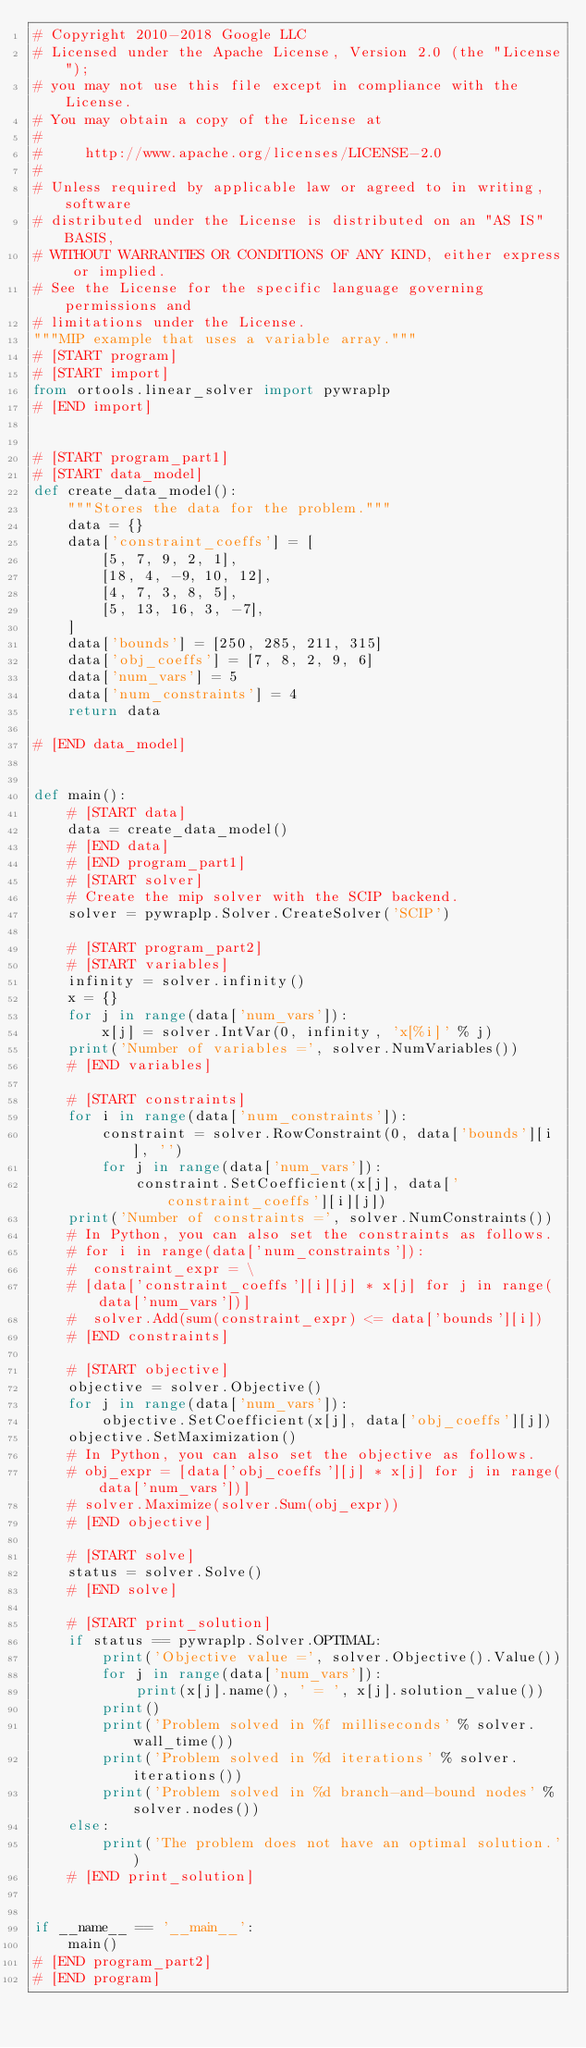Convert code to text. <code><loc_0><loc_0><loc_500><loc_500><_Python_># Copyright 2010-2018 Google LLC
# Licensed under the Apache License, Version 2.0 (the "License");
# you may not use this file except in compliance with the License.
# You may obtain a copy of the License at
#
#     http://www.apache.org/licenses/LICENSE-2.0
#
# Unless required by applicable law or agreed to in writing, software
# distributed under the License is distributed on an "AS IS" BASIS,
# WITHOUT WARRANTIES OR CONDITIONS OF ANY KIND, either express or implied.
# See the License for the specific language governing permissions and
# limitations under the License.
"""MIP example that uses a variable array."""
# [START program]
# [START import]
from ortools.linear_solver import pywraplp
# [END import]


# [START program_part1]
# [START data_model]
def create_data_model():
    """Stores the data for the problem."""
    data = {}
    data['constraint_coeffs'] = [
        [5, 7, 9, 2, 1],
        [18, 4, -9, 10, 12],
        [4, 7, 3, 8, 5],
        [5, 13, 16, 3, -7],
    ]
    data['bounds'] = [250, 285, 211, 315]
    data['obj_coeffs'] = [7, 8, 2, 9, 6]
    data['num_vars'] = 5
    data['num_constraints'] = 4
    return data

# [END data_model]


def main():
    # [START data]
    data = create_data_model()
    # [END data]
    # [END program_part1]
    # [START solver]
    # Create the mip solver with the SCIP backend.
    solver = pywraplp.Solver.CreateSolver('SCIP')

    # [START program_part2]
    # [START variables]
    infinity = solver.infinity()
    x = {}
    for j in range(data['num_vars']):
        x[j] = solver.IntVar(0, infinity, 'x[%i]' % j)
    print('Number of variables =', solver.NumVariables())
    # [END variables]

    # [START constraints]
    for i in range(data['num_constraints']):
        constraint = solver.RowConstraint(0, data['bounds'][i], '')
        for j in range(data['num_vars']):
            constraint.SetCoefficient(x[j], data['constraint_coeffs'][i][j])
    print('Number of constraints =', solver.NumConstraints())
    # In Python, you can also set the constraints as follows.
    # for i in range(data['num_constraints']):
    #  constraint_expr = \
    # [data['constraint_coeffs'][i][j] * x[j] for j in range(data['num_vars'])]
    #  solver.Add(sum(constraint_expr) <= data['bounds'][i])
    # [END constraints]

    # [START objective]
    objective = solver.Objective()
    for j in range(data['num_vars']):
        objective.SetCoefficient(x[j], data['obj_coeffs'][j])
    objective.SetMaximization()
    # In Python, you can also set the objective as follows.
    # obj_expr = [data['obj_coeffs'][j] * x[j] for j in range(data['num_vars'])]
    # solver.Maximize(solver.Sum(obj_expr))
    # [END objective]

    # [START solve]
    status = solver.Solve()
    # [END solve]

    # [START print_solution]
    if status == pywraplp.Solver.OPTIMAL:
        print('Objective value =', solver.Objective().Value())
        for j in range(data['num_vars']):
            print(x[j].name(), ' = ', x[j].solution_value())
        print()
        print('Problem solved in %f milliseconds' % solver.wall_time())
        print('Problem solved in %d iterations' % solver.iterations())
        print('Problem solved in %d branch-and-bound nodes' % solver.nodes())
    else:
        print('The problem does not have an optimal solution.')
    # [END print_solution]


if __name__ == '__main__':
    main()
# [END program_part2]
# [END program]
</code> 